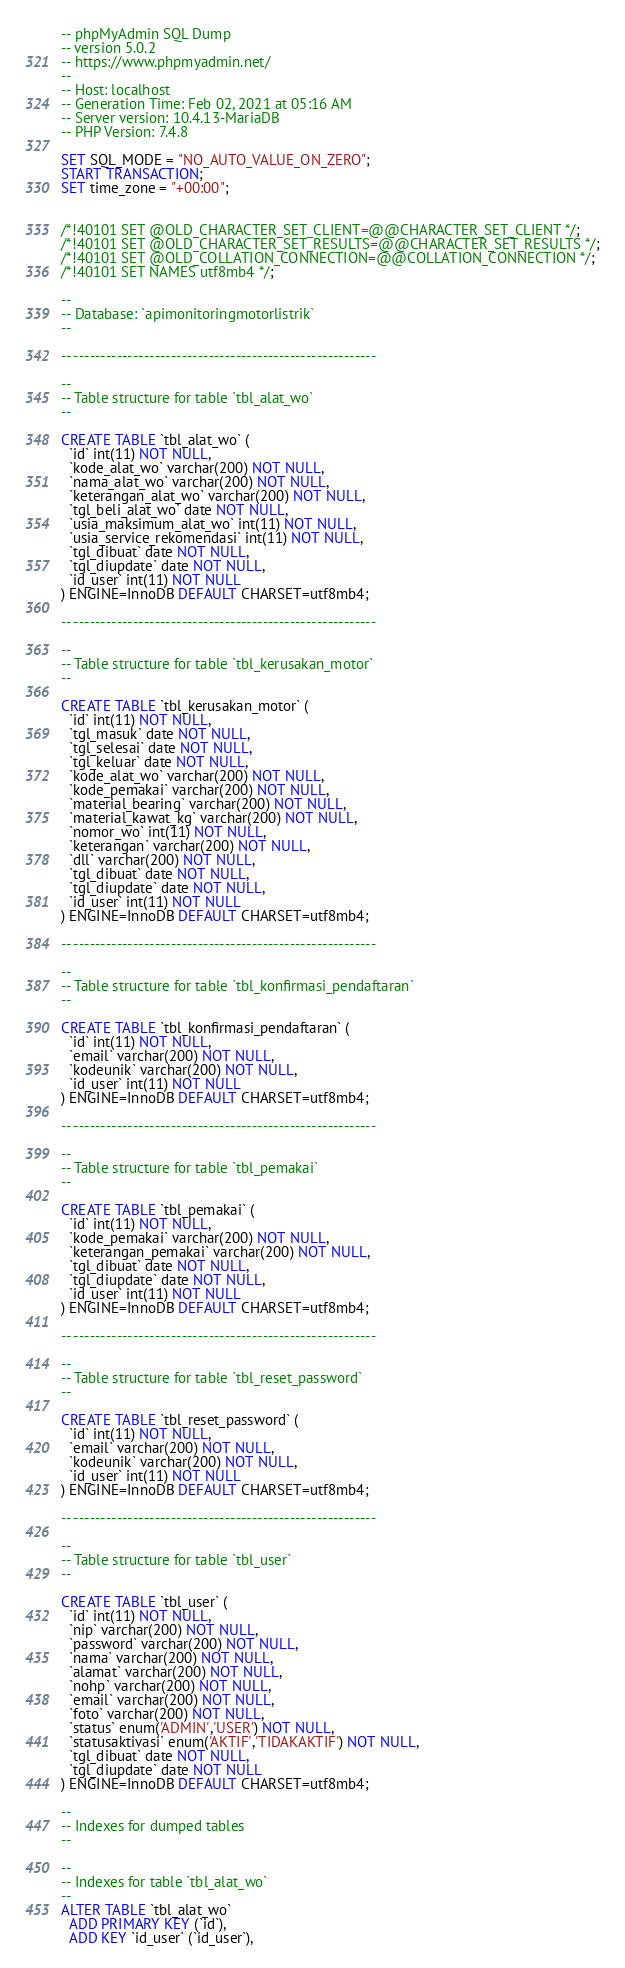Convert code to text. <code><loc_0><loc_0><loc_500><loc_500><_SQL_>-- phpMyAdmin SQL Dump
-- version 5.0.2
-- https://www.phpmyadmin.net/
--
-- Host: localhost
-- Generation Time: Feb 02, 2021 at 05:16 AM
-- Server version: 10.4.13-MariaDB
-- PHP Version: 7.4.8

SET SQL_MODE = "NO_AUTO_VALUE_ON_ZERO";
START TRANSACTION;
SET time_zone = "+00:00";


/*!40101 SET @OLD_CHARACTER_SET_CLIENT=@@CHARACTER_SET_CLIENT */;
/*!40101 SET @OLD_CHARACTER_SET_RESULTS=@@CHARACTER_SET_RESULTS */;
/*!40101 SET @OLD_COLLATION_CONNECTION=@@COLLATION_CONNECTION */;
/*!40101 SET NAMES utf8mb4 */;

--
-- Database: `apimonitoringmotorlistrik`
--

-- --------------------------------------------------------

--
-- Table structure for table `tbl_alat_wo`
--

CREATE TABLE `tbl_alat_wo` (
  `id` int(11) NOT NULL,
  `kode_alat_wo` varchar(200) NOT NULL,
  `nama_alat_wo` varchar(200) NOT NULL,
  `keterangan_alat_wo` varchar(200) NOT NULL,
  `tgl_beli_alat_wo` date NOT NULL,
  `usia_maksimum_alat_wo` int(11) NOT NULL,
  `usia_service_rekomendasi` int(11) NOT NULL,
  `tgl_dibuat` date NOT NULL,
  `tgl_diupdate` date NOT NULL,
  `id_user` int(11) NOT NULL
) ENGINE=InnoDB DEFAULT CHARSET=utf8mb4;

-- --------------------------------------------------------

--
-- Table structure for table `tbl_kerusakan_motor`
--

CREATE TABLE `tbl_kerusakan_motor` (
  `id` int(11) NOT NULL,
  `tgl_masuk` date NOT NULL,
  `tgl_selesai` date NOT NULL,
  `tgl_keluar` date NOT NULL,
  `kode_alat_wo` varchar(200) NOT NULL,
  `kode_pemakai` varchar(200) NOT NULL,
  `material_bearing` varchar(200) NOT NULL,
  `material_kawat_kg` varchar(200) NOT NULL,
  `nomor_wo` int(11) NOT NULL,
  `keterangan` varchar(200) NOT NULL,
  `dll` varchar(200) NOT NULL,
  `tgl_dibuat` date NOT NULL,
  `tgl_diupdate` date NOT NULL,
  `id_user` int(11) NOT NULL
) ENGINE=InnoDB DEFAULT CHARSET=utf8mb4;

-- --------------------------------------------------------

--
-- Table structure for table `tbl_konfirmasi_pendaftaran`
--

CREATE TABLE `tbl_konfirmasi_pendaftaran` (
  `id` int(11) NOT NULL,
  `email` varchar(200) NOT NULL,
  `kodeunik` varchar(200) NOT NULL,
  `id_user` int(11) NOT NULL
) ENGINE=InnoDB DEFAULT CHARSET=utf8mb4;

-- --------------------------------------------------------

--
-- Table structure for table `tbl_pemakai`
--

CREATE TABLE `tbl_pemakai` (
  `id` int(11) NOT NULL,
  `kode_pemakai` varchar(200) NOT NULL,
  `keterangan_pemakai` varchar(200) NOT NULL,
  `tgl_dibuat` date NOT NULL,
  `tgl_diupdate` date NOT NULL,
  `id_user` int(11) NOT NULL
) ENGINE=InnoDB DEFAULT CHARSET=utf8mb4;

-- --------------------------------------------------------

--
-- Table structure for table `tbl_reset_password`
--

CREATE TABLE `tbl_reset_password` (
  `id` int(11) NOT NULL,
  `email` varchar(200) NOT NULL,
  `kodeunik` varchar(200) NOT NULL,
  `id_user` int(11) NOT NULL
) ENGINE=InnoDB DEFAULT CHARSET=utf8mb4;

-- --------------------------------------------------------

--
-- Table structure for table `tbl_user`
--

CREATE TABLE `tbl_user` (
  `id` int(11) NOT NULL,
  `nip` varchar(200) NOT NULL,
  `password` varchar(200) NOT NULL,
  `nama` varchar(200) NOT NULL,
  `alamat` varchar(200) NOT NULL,
  `nohp` varchar(200) NOT NULL,
  `email` varchar(200) NOT NULL,
  `foto` varchar(200) NOT NULL,
  `status` enum('ADMIN','USER') NOT NULL,
  `statusaktivasi` enum('AKTIF','TIDAKAKTIF') NOT NULL,
  `tgl_dibuat` date NOT NULL,
  `tgl_diupdate` date NOT NULL
) ENGINE=InnoDB DEFAULT CHARSET=utf8mb4;

--
-- Indexes for dumped tables
--

--
-- Indexes for table `tbl_alat_wo`
--
ALTER TABLE `tbl_alat_wo`
  ADD PRIMARY KEY (`id`),
  ADD KEY `id_user` (`id_user`),</code> 